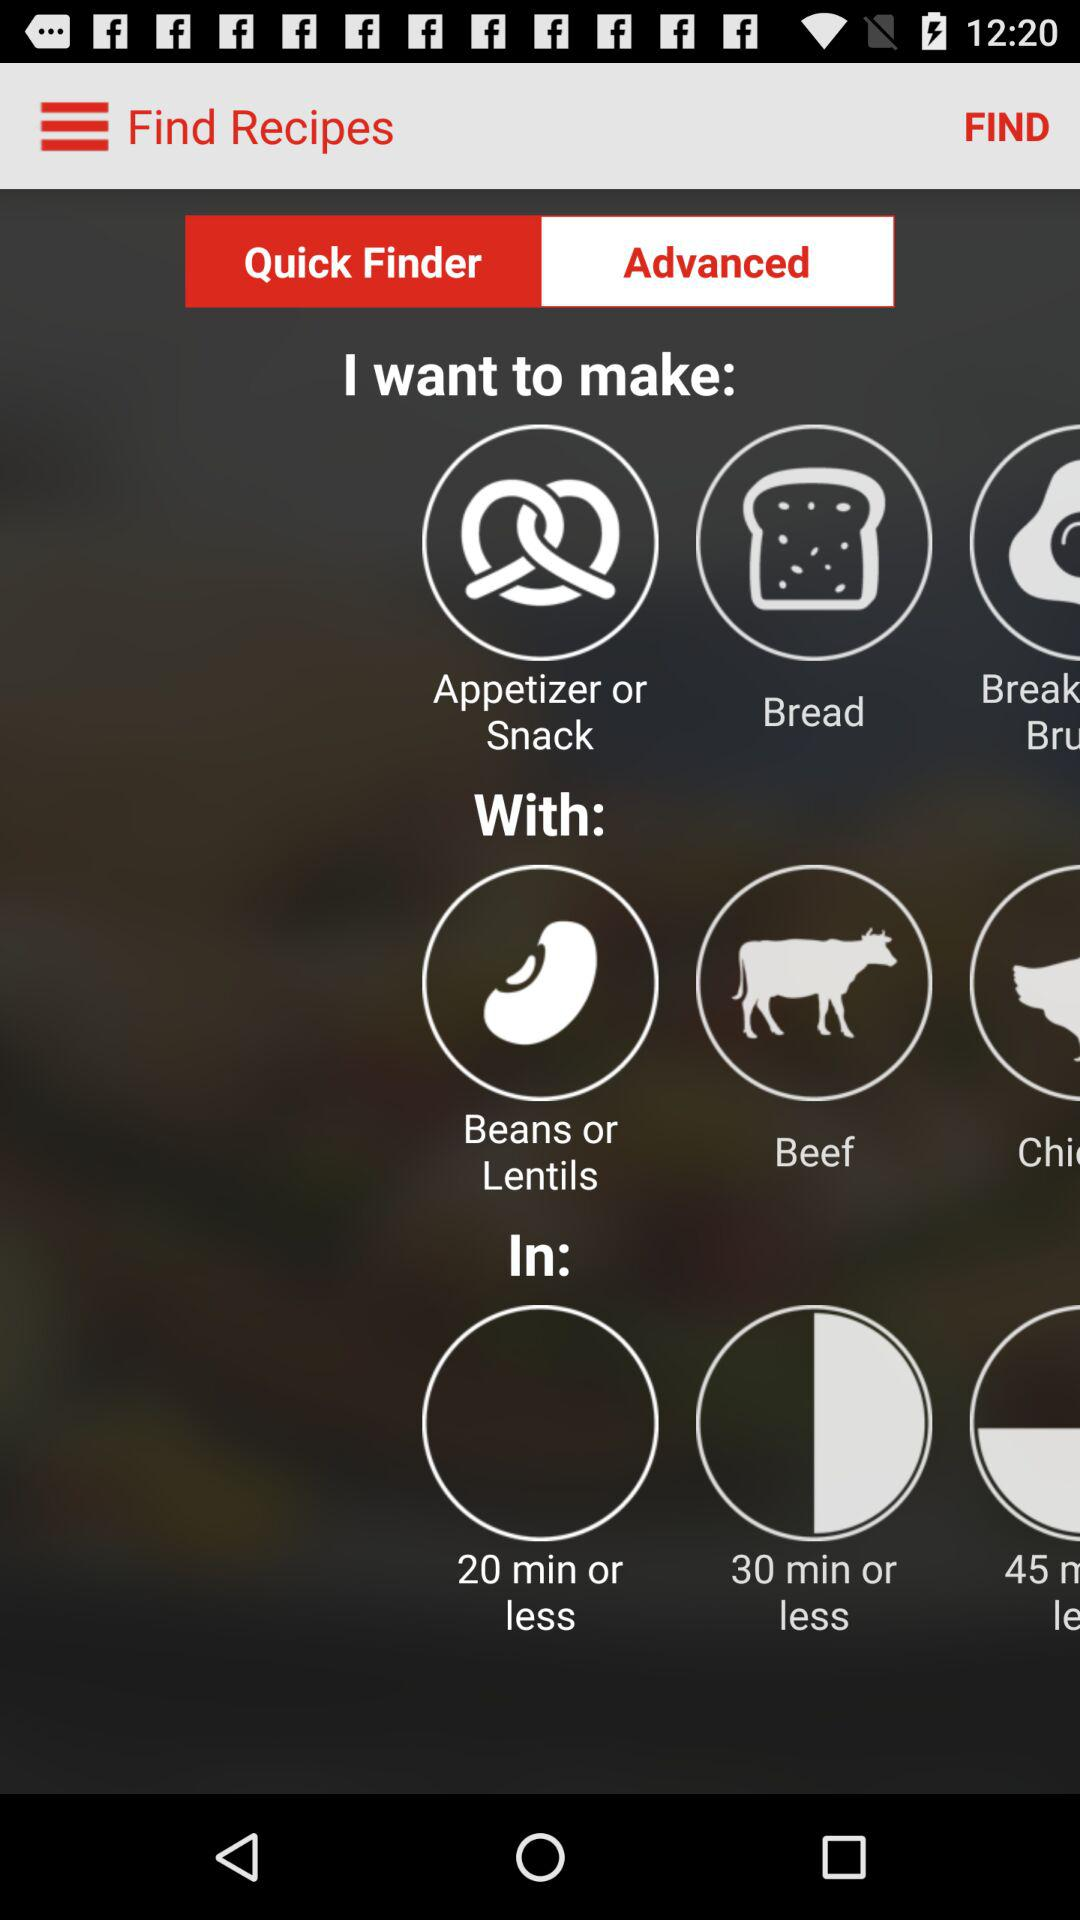Which recipes do I prepare? You can prepare "Appetizer or Snack", "Bread", and "Break Bru". 